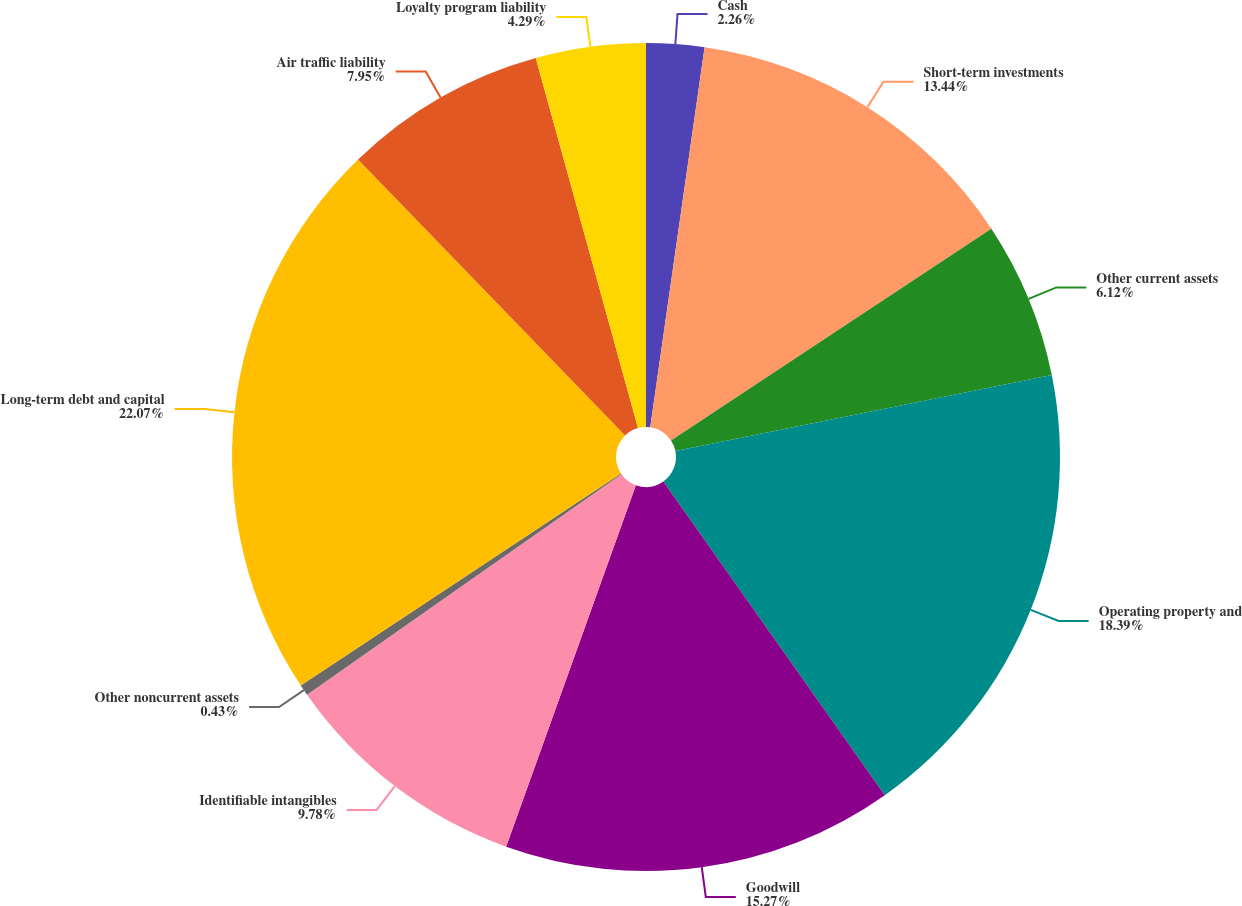<chart> <loc_0><loc_0><loc_500><loc_500><pie_chart><fcel>Cash<fcel>Short-term investments<fcel>Other current assets<fcel>Operating property and<fcel>Goodwill<fcel>Identifiable intangibles<fcel>Other noncurrent assets<fcel>Long-term debt and capital<fcel>Air traffic liability<fcel>Loyalty program liability<nl><fcel>2.26%<fcel>13.44%<fcel>6.12%<fcel>18.39%<fcel>15.27%<fcel>9.78%<fcel>0.43%<fcel>22.06%<fcel>7.95%<fcel>4.29%<nl></chart> 